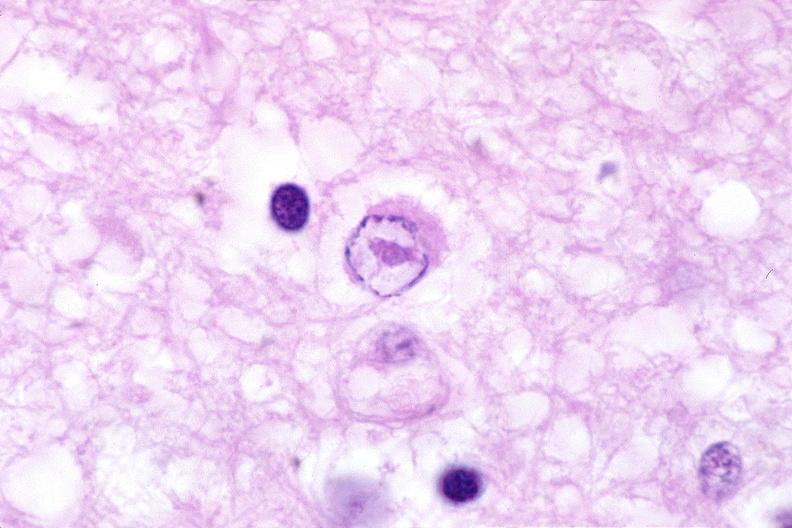what is present?
Answer the question using a single word or phrase. Nervous 